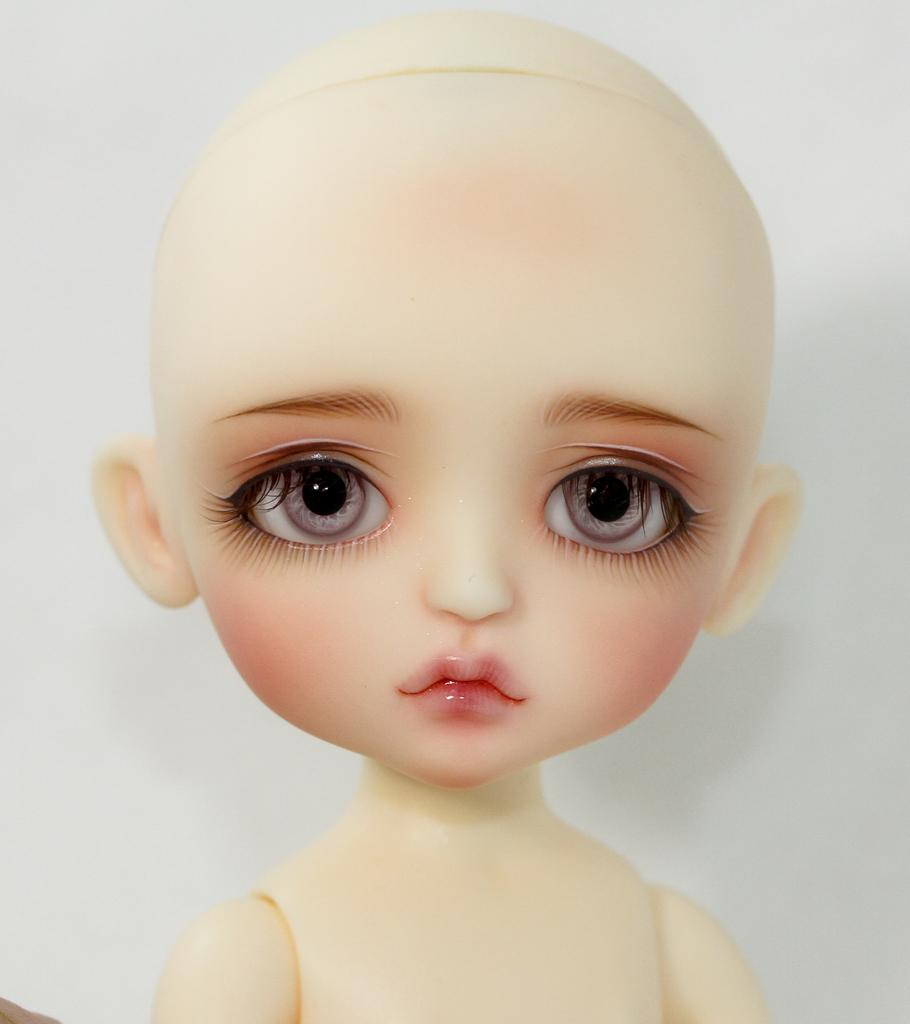What object can be seen in the image? There is a toy in the image. What color is the background of the image? The background of the image is white. How many horses are visible in the image? There are no horses present in the image; it features a toy and a white background. What type of zipper can be seen on the toy in the image? There is no zipper present on the toy in the image. 